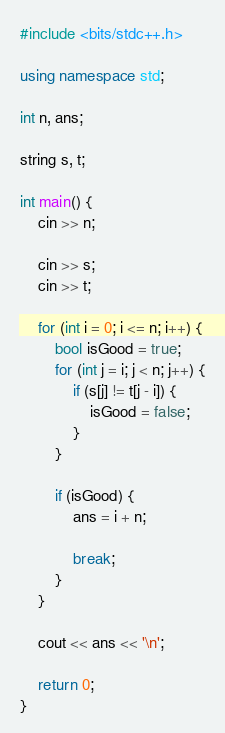<code> <loc_0><loc_0><loc_500><loc_500><_C++_>#include <bits/stdc++.h>

using namespace std;

int n, ans;

string s, t;

int main() {
    cin >> n;

    cin >> s;
    cin >> t;

    for (int i = 0; i <= n; i++) {
        bool isGood = true;
        for (int j = i; j < n; j++) {
            if (s[j] != t[j - i]) {
                isGood = false;
            }
        }

        if (isGood) {
            ans = i + n;

            break;
        }
    }

    cout << ans << '\n';

    return 0;
}
</code> 